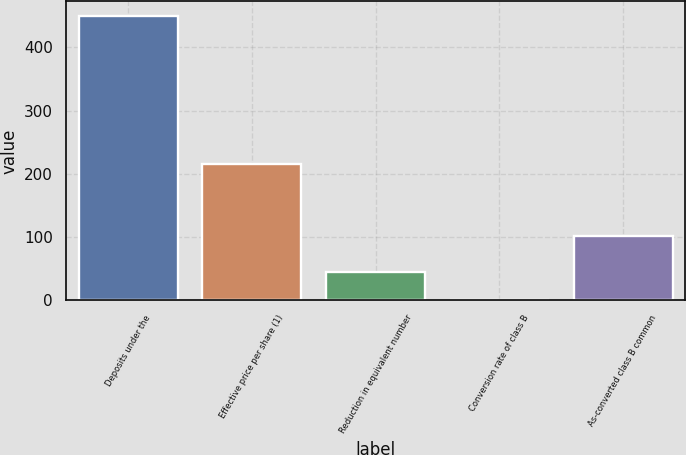<chart> <loc_0><loc_0><loc_500><loc_500><bar_chart><fcel>Deposits under the<fcel>Effective price per share (1)<fcel>Reduction in equivalent number<fcel>Conversion rate of class B<fcel>As-converted class B common<nl><fcel>450<fcel>215.33<fcel>45.37<fcel>0.41<fcel>101<nl></chart> 